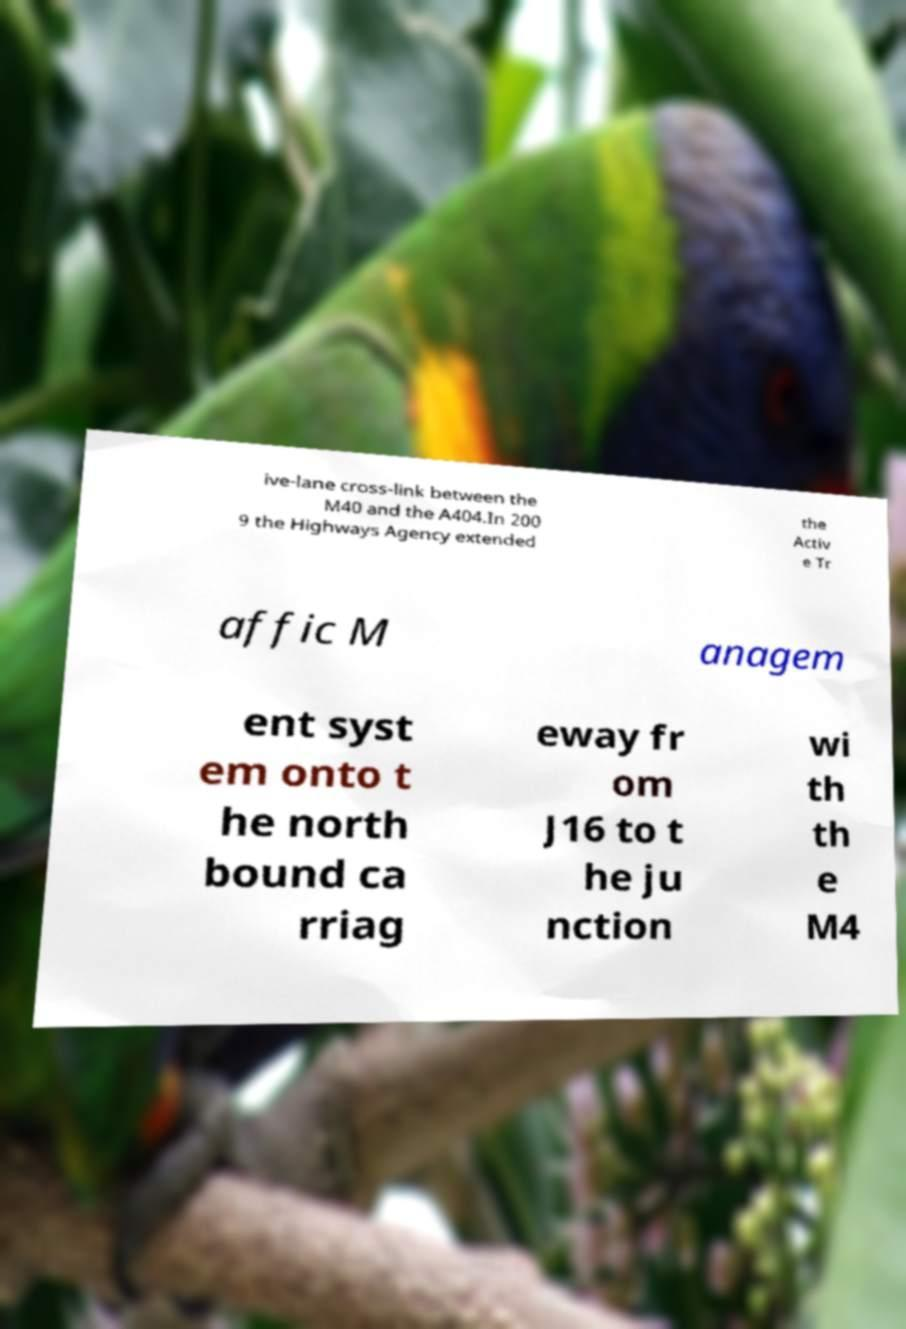Could you extract and type out the text from this image? ive-lane cross-link between the M40 and the A404.In 200 9 the Highways Agency extended the Activ e Tr affic M anagem ent syst em onto t he north bound ca rriag eway fr om J16 to t he ju nction wi th th e M4 